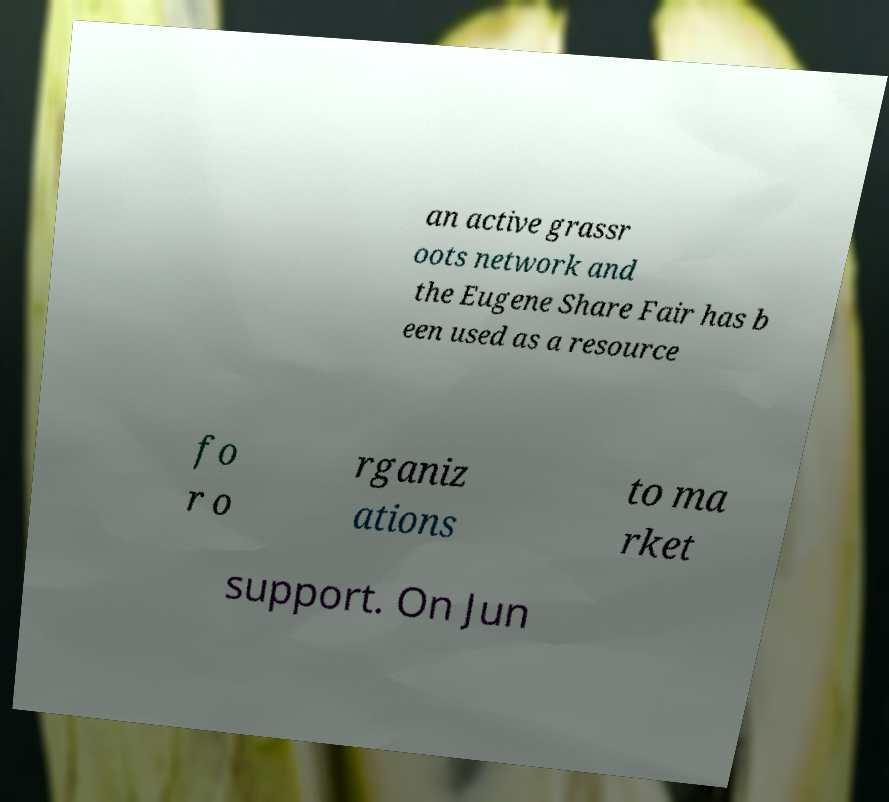There's text embedded in this image that I need extracted. Can you transcribe it verbatim? an active grassr oots network and the Eugene Share Fair has b een used as a resource fo r o rganiz ations to ma rket support. On Jun 